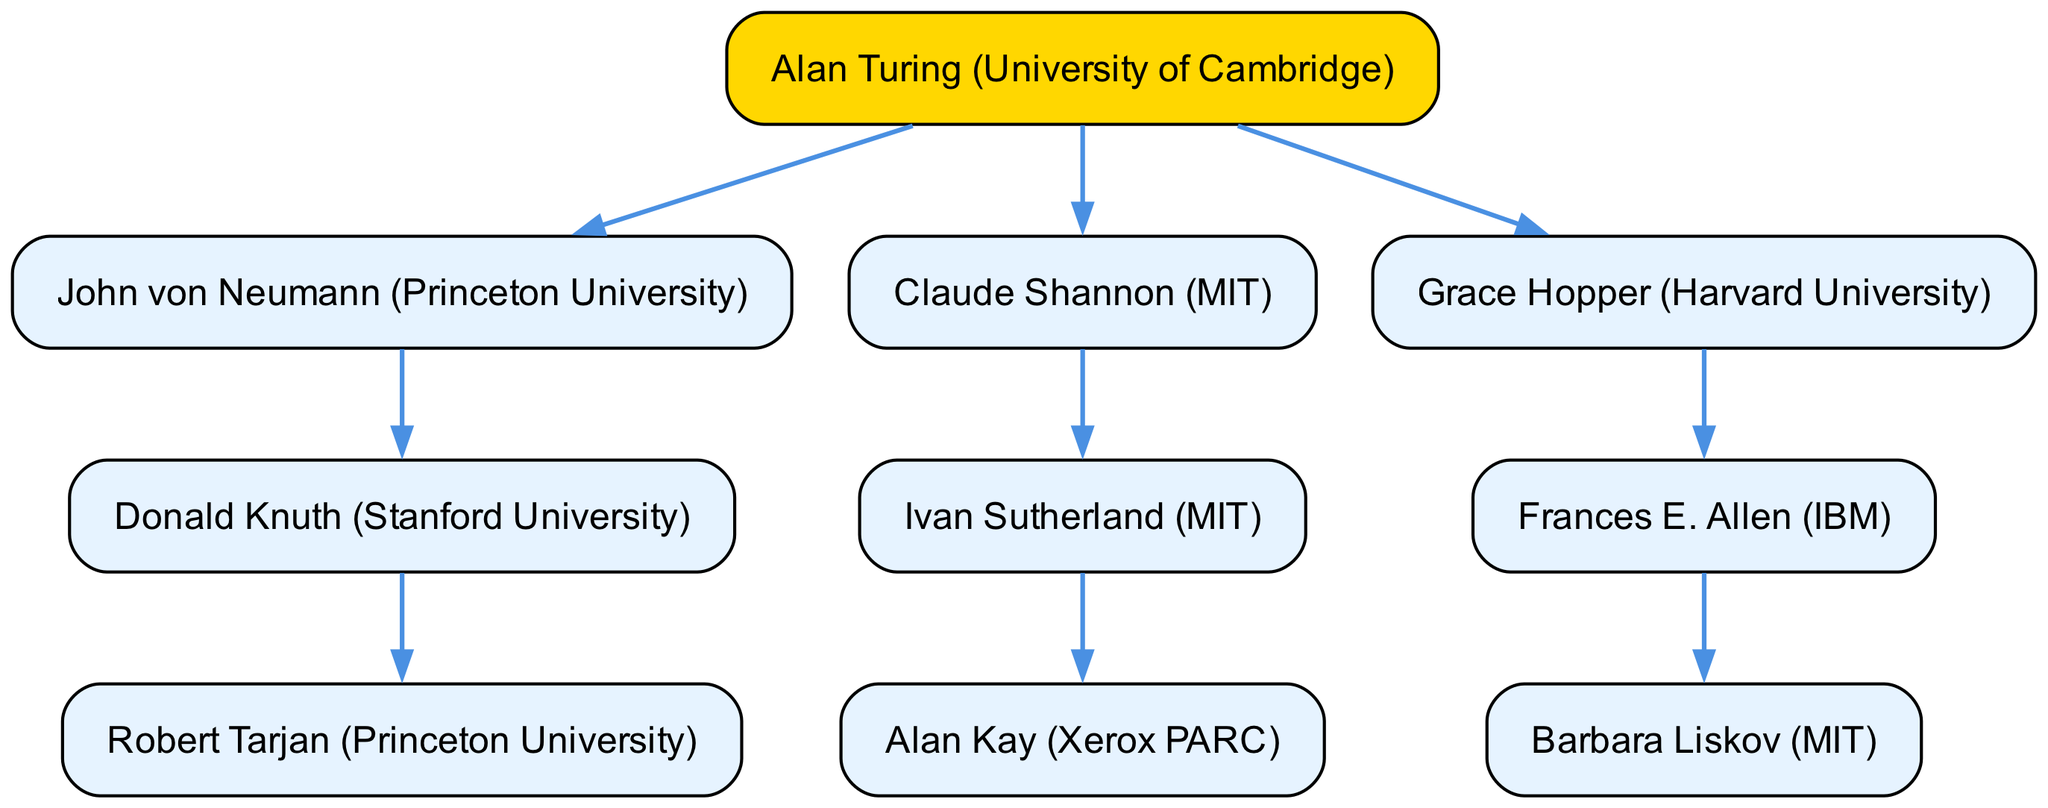What is the root node of the family tree? The root node represents the starting point of the family tree and is labeled "Alan Turing (University of Cambridge)".
Answer: Alan Turing (University of Cambridge) How many children does Claude Shannon have? Claude Shannon is connected to one child, which is Ivan Sutherland (MIT). This is confirmed by counting the direct descendants under his node.
Answer: 1 Who is the child of John von Neumann? The diagram indicates that John von Neumann has one child, Donald Knuth (Stanford University), directly linked to his node.
Answer: Donald Knuth (Stanford University) Which university is associated with Grace Hopper? By examining the node for Grace Hopper, we can see that it states "Grace Hopper (Harvard University)", directly identifying the university linked to her.
Answer: Harvard University Which pioneer is the grandchild of Claude Shannon? To determine this, we trace the lineage: Claude Shannon has Ivan Sutherland as a child, who in turn has Alan Kay as a child. Thus, Alan Kay is the grandchild of Claude Shannon.
Answer: Alan Kay (Xerox PARC) How many nodes are in total in the family tree? By counting all the distinct nodes in the diagram—root, children, and grandchildren—we find a total of 8 nodes: Alan Turing, John von Neumann, Donald Knuth, Robert Tarjan, Claude Shannon, Ivan Sutherland, Alan Kay, Grace Hopper, Frances E. Allen, and Barbara Liskov.
Answer: 10 Who is the child of Frances E. Allen? The diagram shows that Frances E. Allen has one child, which is Barbara Liskov (MIT), as indicated under her node.
Answer: Barbara Liskov (MIT) What is the relationship between Donald Knuth and Robert Tarjan? Tracing the connections: Donald Knuth is a direct parent of Robert Tarjan, making them parent and child respectively in the lineage.
Answer: Parent and child What is the direct academic lineage of Alan Kay? Alan Kay is shown as a child of Ivan Sutherland, who is in turn a child of Claude Shannon. The lineage flows from Claude Shannon to Ivan Sutherland, and then to Alan Kay.
Answer: Claude Shannon → Ivan Sutherland → Alan Kay 